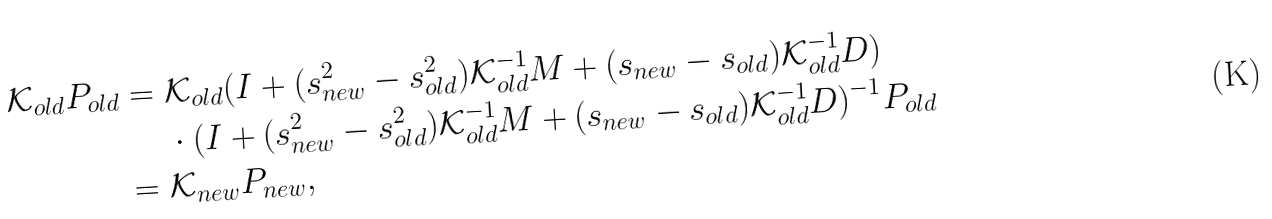<formula> <loc_0><loc_0><loc_500><loc_500>\mathcal { K } _ { o l d } P _ { o l d } = & \ \mathcal { K } _ { o l d } ( I + ( s ^ { 2 } _ { n e w } - s ^ { 2 } _ { o l d } ) \mathcal { K } _ { o l d } ^ { - 1 } M + ( s _ { n e w } - s _ { o l d } ) \mathcal { K } _ { o l d } ^ { - 1 } D ) \\ & \ \cdot ( I + ( s ^ { 2 } _ { n e w } - s ^ { 2 } _ { o l d } ) \mathcal { K } _ { o l d } ^ { - 1 } M + ( s _ { n e w } - s _ { o l d } ) \mathcal { K } _ { o l d } ^ { - 1 } D ) ^ { - 1 } P _ { o l d } \\ = & \ \mathcal { K } _ { n e w } P _ { n e w } ,</formula> 